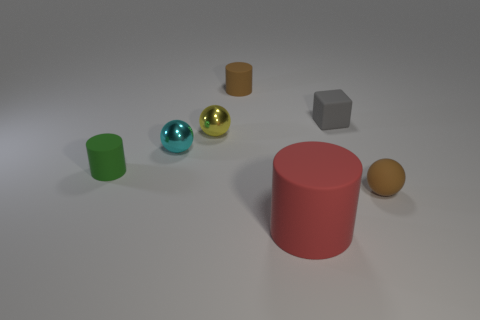Subtract all brown matte spheres. How many spheres are left? 2 Subtract 1 balls. How many balls are left? 2 Add 2 small matte cylinders. How many objects exist? 9 Subtract all cubes. How many objects are left? 6 Subtract all large things. Subtract all red matte things. How many objects are left? 5 Add 1 large rubber things. How many large rubber things are left? 2 Add 6 big cylinders. How many big cylinders exist? 7 Subtract 1 brown cylinders. How many objects are left? 6 